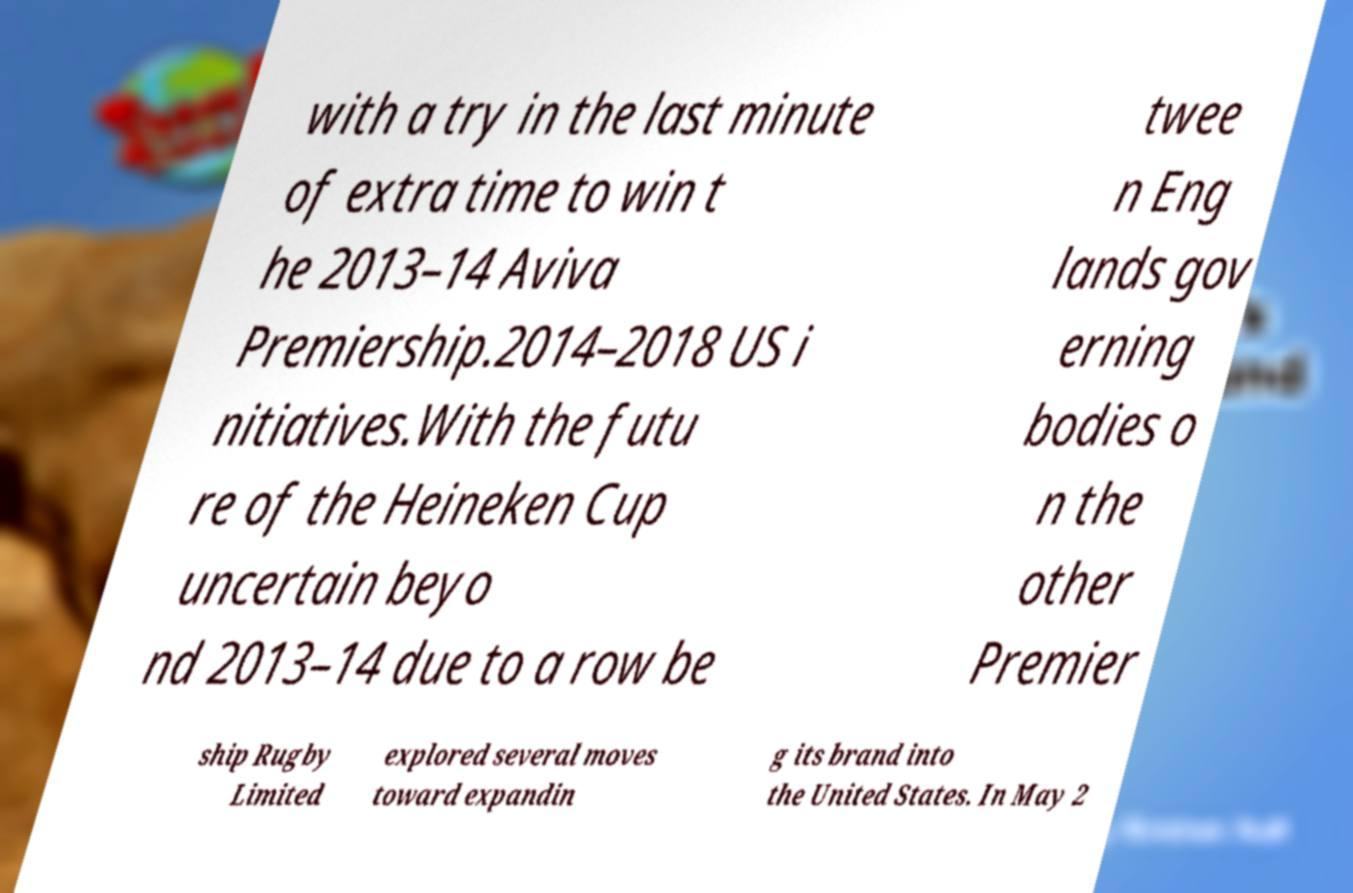Can you accurately transcribe the text from the provided image for me? with a try in the last minute of extra time to win t he 2013–14 Aviva Premiership.2014–2018 US i nitiatives.With the futu re of the Heineken Cup uncertain beyo nd 2013–14 due to a row be twee n Eng lands gov erning bodies o n the other Premier ship Rugby Limited explored several moves toward expandin g its brand into the United States. In May 2 